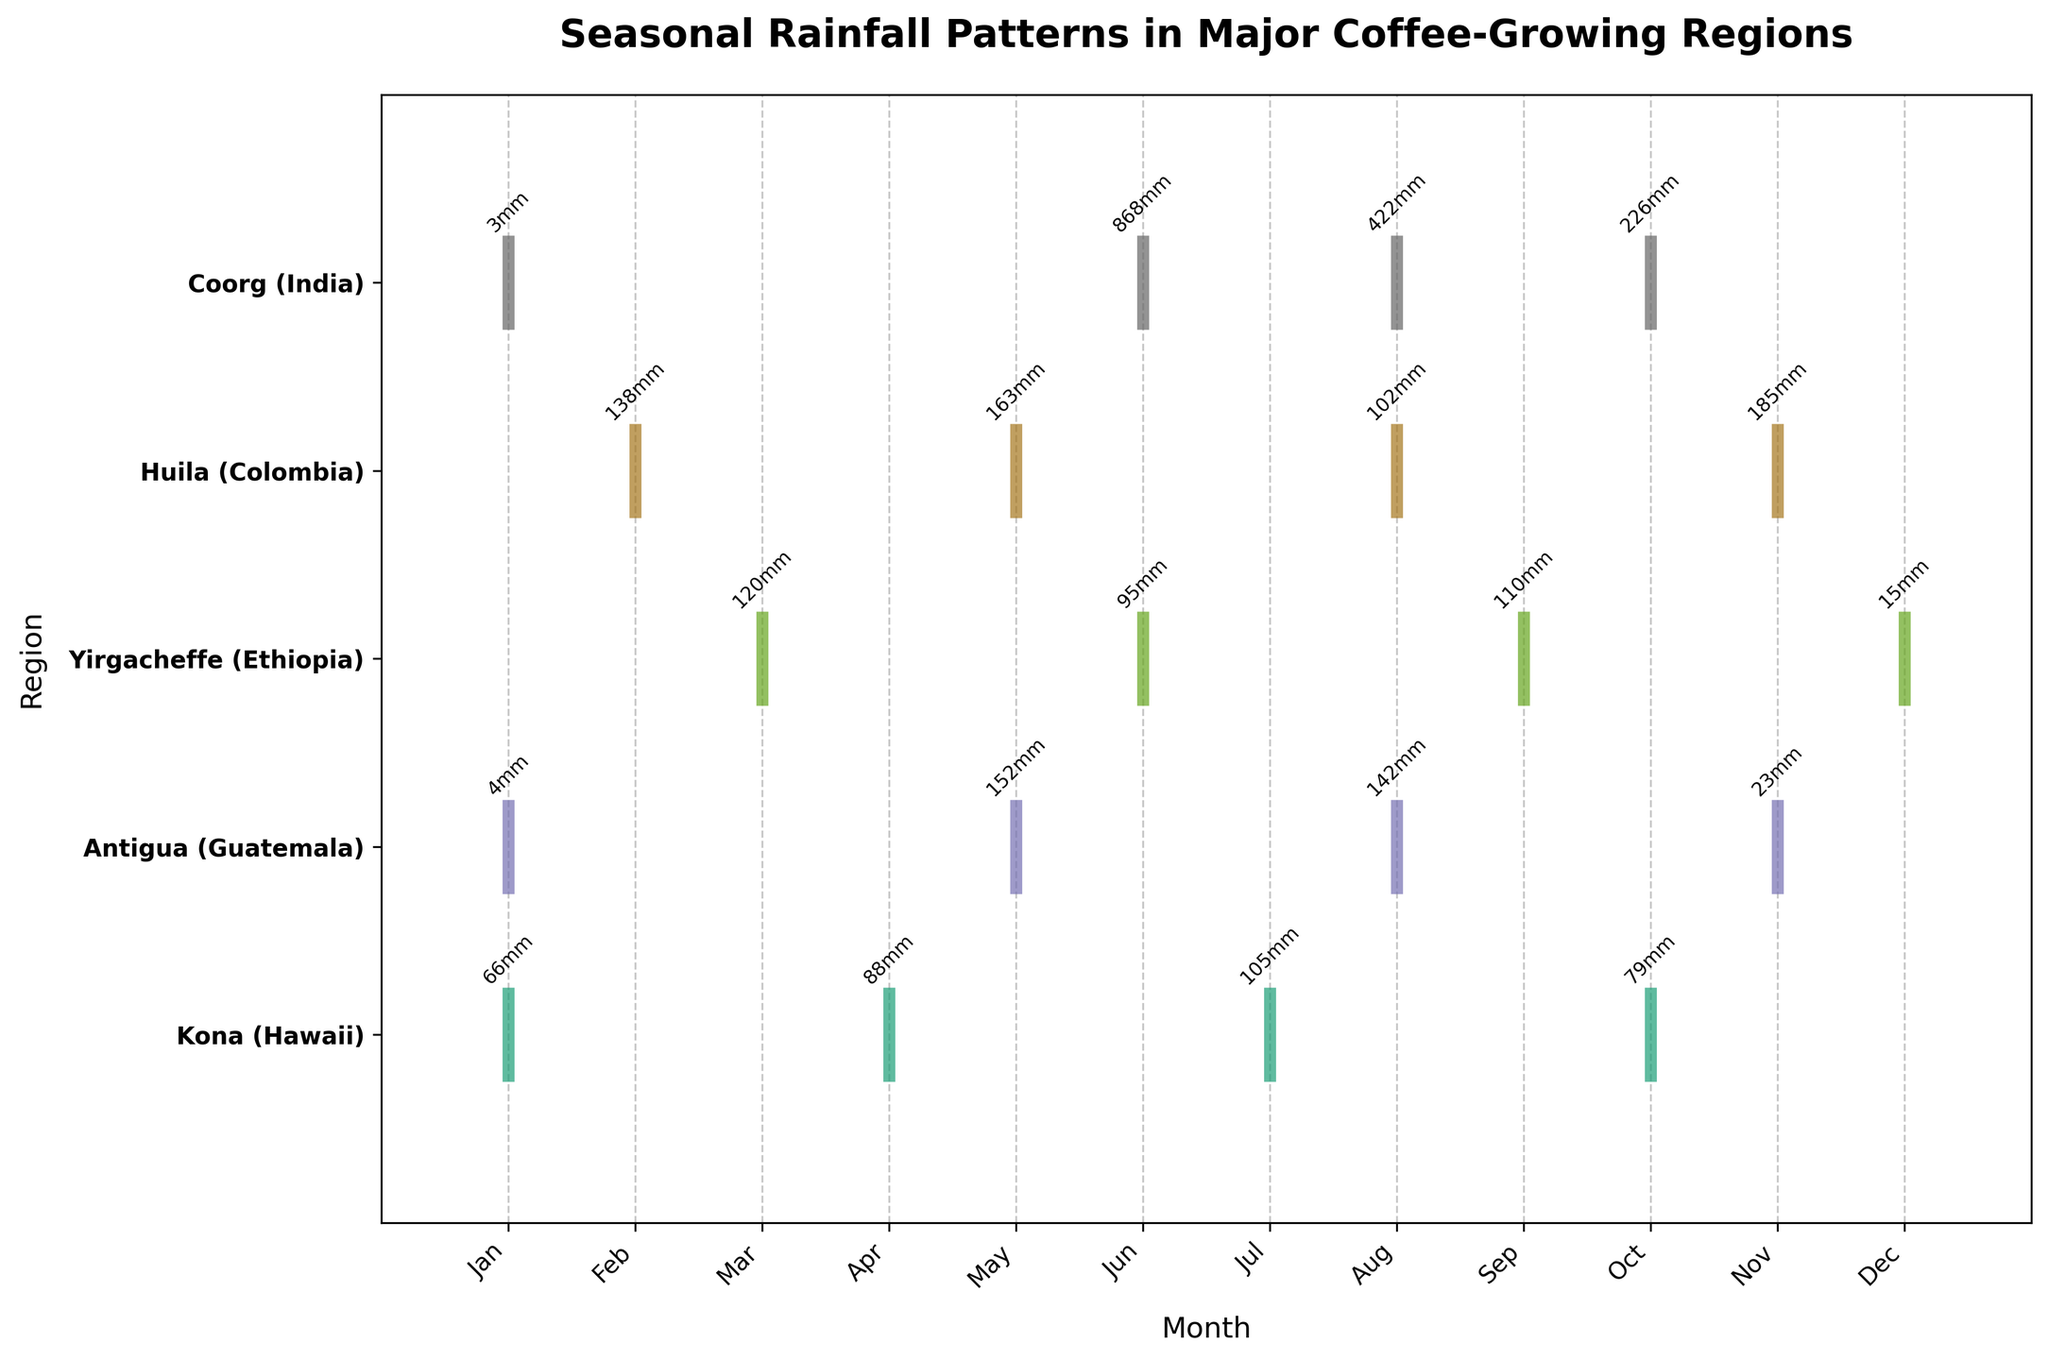What is the title of the figure? The title is usually located at the top of the plot and is designed to give an overview of what the data represents. In this case, the title reads "Seasonal Rainfall Patterns in Major Coffee-Growing Regions."
Answer: Seasonal Rainfall Patterns in Major Coffee-Growing Regions How many regions are depicted in the figure? By counting the number of unique entries on the y-axis, which represents different regions, we can determine there are five regions shown.
Answer: 5 Which region has the highest rainfall in any single month, and how much is it? Inspecting the annotated rainfall values on the plot, we see Coorg (India) shows the highest value of 868 mm in June.
Answer: Coorg in June with 868mm During which month does Antigua (Guatemala) experience its peak rainfall? We need to find the month with the highest annotated rainfall value for Antigua (Guatemala). May has the highest value at 152 mm.
Answer: May Which month has the maximum number of regions with recorded rainfall data? By noting the number of rainfall records per month, the month of August has the highest occurrence, with four regions—Antigua, Yirgacheffe, Huila, and Coorg—having data points.
Answer: August What's the average rainfall for Huila (Colombia) across the recorded months? Adding rainfall amounts for Huila (Colombia) (138 + 163 + 102 + 185 = 588 mm) and dividing by the number of recorded months (4) gives: 588/4 = 147 mm.
Answer: 147 mm Compare the rainfall patterns of Kona (Hawaii) and Yirgacheffe (Ethiopia), and identify which region is wetter on average. Calculate the average rainfall for both regions. Kona (Hawaii): (66 + 88 + 105 + 79)/4 = 84.5 mm; Yirgacheffe (Ethiopia): (120 + 95 + 110 + 15)/4 = 85 mm. Yirgacheffe has a slightly higher average rainfall.
Answer: Yirgacheffe In which month does Yirgacheffe (Ethiopia) have its lowest recorded rainfall? Looking at the annotated rainfall values, Yirgacheffe (Ethiopia) has its lowest recorded rainfall in December with 15 mm.
Answer: December Which region has more consistent rainfall throughout the year in terms of deviation from the average? By inspecting how spread out the rainfall values are around the mean for each region, Kona (Hawaii) shows more evenly spread values (66, 88, 105, 79) compared to the others, indicating a more consistent pattern.
Answer: Kona 